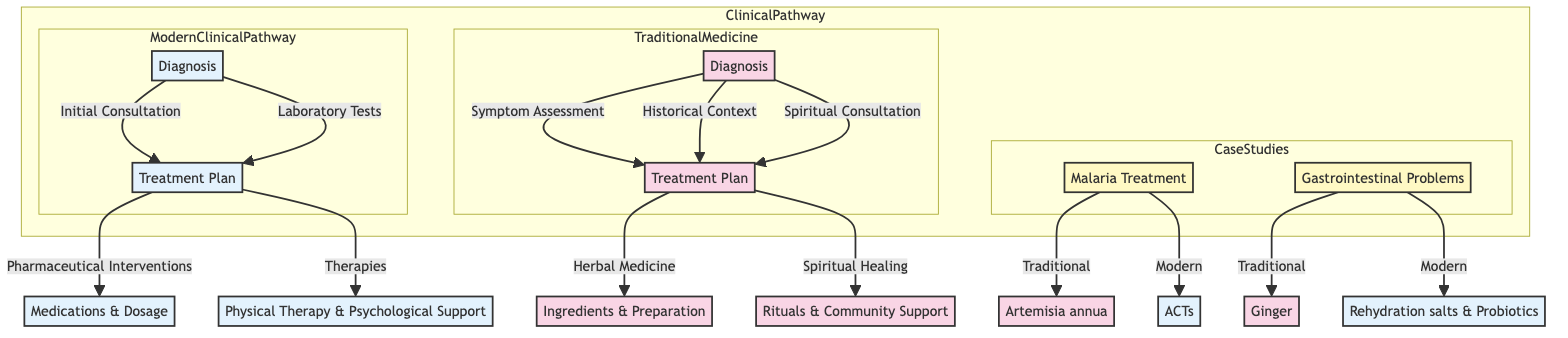What are the components of the Traditional Medicine diagnosis? The Traditional Medicine diagnosis includes "Symptom Assessment," "Historical Context," and "Spiritual Consultation." These components can be seen as separate nodes leading to the treatment plan in the diagram.
Answer: Symptom Assessment, Historical Context, Spiritual Consultation How many branches are there in the Modern Clinical Pathway treatment plan? The Modern Clinical Pathway treatment plan has two branches: "Pharmaceutical Interventions" and "Therapies." Each represents a distinct approach to treatment.
Answer: 2 What is the traditional remedy used for malaria treatment? The traditional remedy used for malaria treatment, as shown in the diagram, is "Artemisia annua." This is connected to the case study on malaria treatment in the Traditional approach section.
Answer: Artemisia annua Which part of the Traditional Medicine diagnosis involves family knowledge? The component of the Traditional Medicine diagnosis that involves family knowledge is "Historical Context." This is one of the specific elements outlined in the diagram.
Answer: Historical Context What type of tests are part of the Modern Clinical Pathway diagnosis? The Modern Clinical Pathway diagnosis includes "Laboratory Tests," which encompasses various types of tests such as blood tests and imaging. This represents a critical aspect of modern diagnostics.
Answer: Laboratory Tests What is one method mentioned in the Traditional Medicine treatment plan? One method in the Traditional Medicine treatment plan is "Herbal Medicine," which includes the use of known plant species and traditional preparation methods, reflecting the holistic approach of traditional healing.
Answer: Herbal Medicine What is the modern treatment for gastrointestinal problems? The modern treatment for gastrointestinal problems is "rehydration salts and probiotics," which is prescribed according to the modern clinical pathway as indicated in the case studies section.
Answer: rehydration salts and probiotics In the diagram, which component does "Ceremonial practices" belong to? "Ceremonial practices" belong to the "Spiritual Healing" component of the Traditional Medicine treatment plan, highlighting the cultural significance of rituals in the healing process.
Answer: Spiritual Healing What type of support is included in the therapies of the Modern Clinical Pathway? The therapies in the Modern Clinical Pathway include "Psychological Support." This emphasizes the importance of mental health services within modern treatment frameworks.
Answer: Psychological Support 